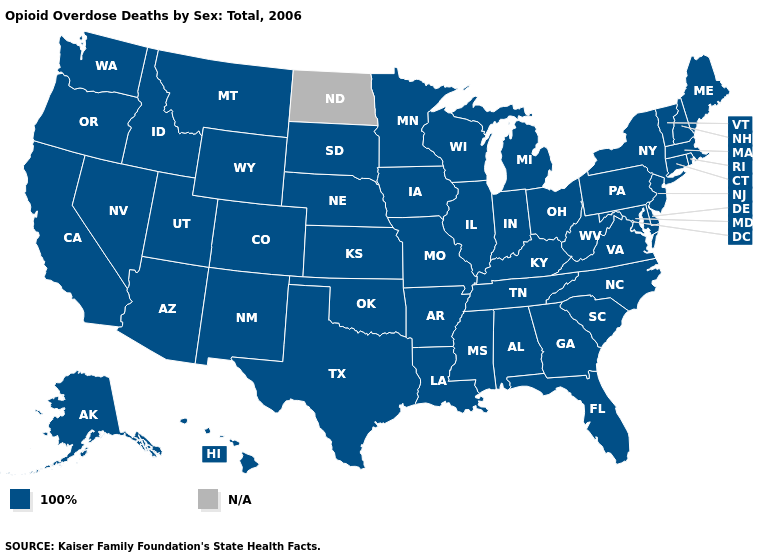Name the states that have a value in the range 100%?
Give a very brief answer. Alabama, Alaska, Arizona, Arkansas, California, Colorado, Connecticut, Delaware, Florida, Georgia, Hawaii, Idaho, Illinois, Indiana, Iowa, Kansas, Kentucky, Louisiana, Maine, Maryland, Massachusetts, Michigan, Minnesota, Mississippi, Missouri, Montana, Nebraska, Nevada, New Hampshire, New Jersey, New Mexico, New York, North Carolina, Ohio, Oklahoma, Oregon, Pennsylvania, Rhode Island, South Carolina, South Dakota, Tennessee, Texas, Utah, Vermont, Virginia, Washington, West Virginia, Wisconsin, Wyoming. Does the first symbol in the legend represent the smallest category?
Quick response, please. Yes. Is the legend a continuous bar?
Short answer required. No. Name the states that have a value in the range N/A?
Keep it brief. North Dakota. Among the states that border Idaho , which have the highest value?
Give a very brief answer. Montana, Nevada, Oregon, Utah, Washington, Wyoming. What is the lowest value in the South?
Answer briefly. 100%. Which states have the lowest value in the USA?
Write a very short answer. Alabama, Alaska, Arizona, Arkansas, California, Colorado, Connecticut, Delaware, Florida, Georgia, Hawaii, Idaho, Illinois, Indiana, Iowa, Kansas, Kentucky, Louisiana, Maine, Maryland, Massachusetts, Michigan, Minnesota, Mississippi, Missouri, Montana, Nebraska, Nevada, New Hampshire, New Jersey, New Mexico, New York, North Carolina, Ohio, Oklahoma, Oregon, Pennsylvania, Rhode Island, South Carolina, South Dakota, Tennessee, Texas, Utah, Vermont, Virginia, Washington, West Virginia, Wisconsin, Wyoming. How many symbols are there in the legend?
Write a very short answer. 2. Name the states that have a value in the range 100%?
Keep it brief. Alabama, Alaska, Arizona, Arkansas, California, Colorado, Connecticut, Delaware, Florida, Georgia, Hawaii, Idaho, Illinois, Indiana, Iowa, Kansas, Kentucky, Louisiana, Maine, Maryland, Massachusetts, Michigan, Minnesota, Mississippi, Missouri, Montana, Nebraska, Nevada, New Hampshire, New Jersey, New Mexico, New York, North Carolina, Ohio, Oklahoma, Oregon, Pennsylvania, Rhode Island, South Carolina, South Dakota, Tennessee, Texas, Utah, Vermont, Virginia, Washington, West Virginia, Wisconsin, Wyoming. 